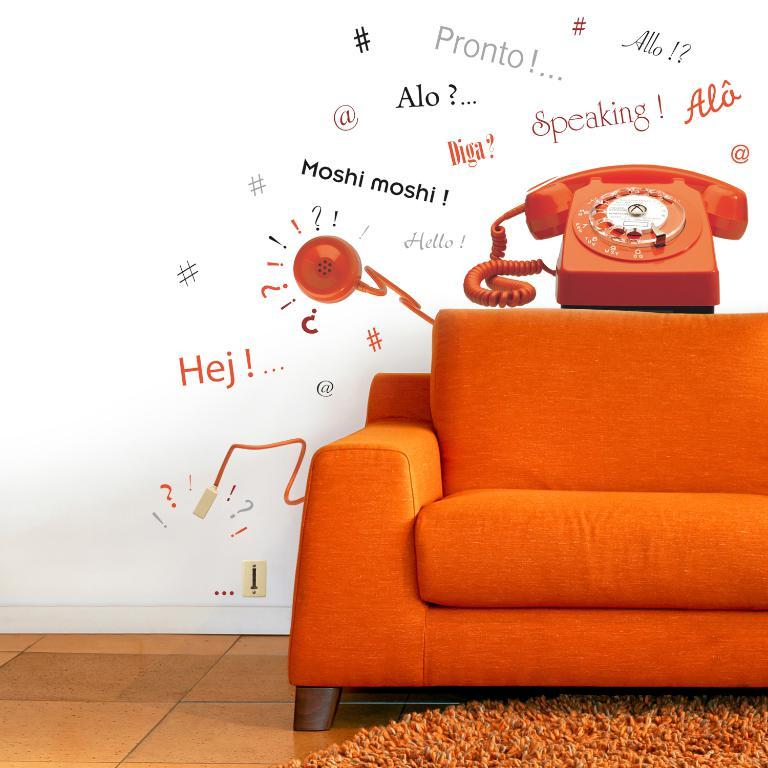What color is the sofa in the image? The sofa in the image is orange. What is placed on the orange sofa? There is a phone on the orange sofa. What color is the carpet in the image? The carpet in the image is orange. What color is the wall in the image? The wall in the image is white. What can be seen on the white wall? There are many texts on the wall. Can you see a pipe in the image? There is no pipe present in the image. What type of hope is depicted on the orange sofa? There is no depiction of hope in the image; it features an orange sofa, a phone, an orange carpet, a white wall, and many texts on the wall. 